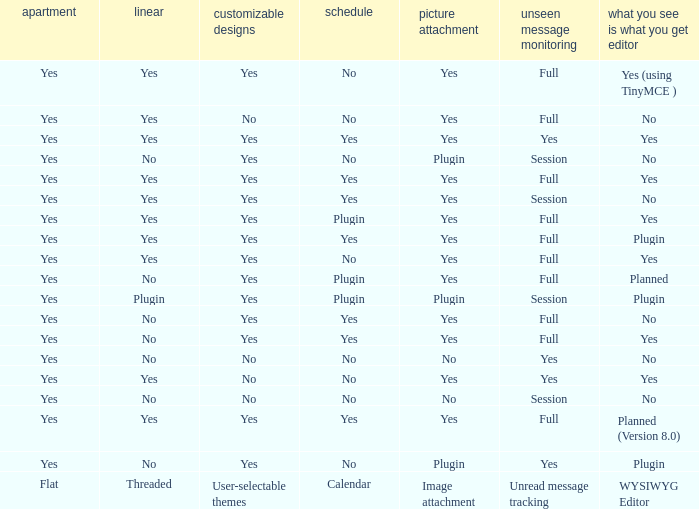Which WYSIWYG Editor has an Image attachment of yes, and a Calendar of plugin? Yes, Planned. 